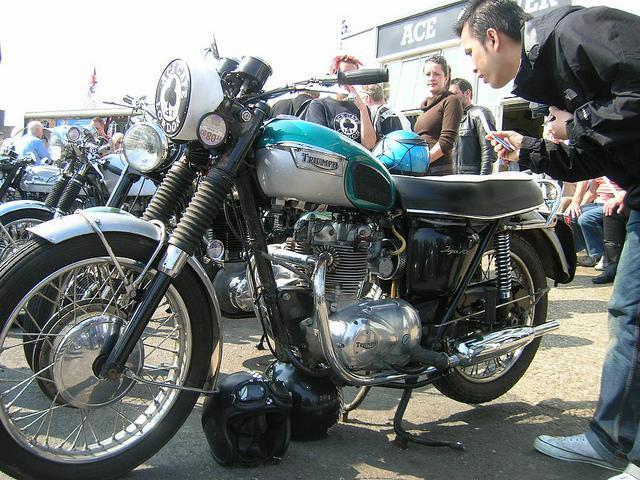How many different shades of blue are on the motorcycle?
Give a very brief answer. 1. How many people are there?
Give a very brief answer. 5. How many motorcycles can be seen?
Give a very brief answer. 3. 